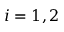<formula> <loc_0><loc_0><loc_500><loc_500>i = 1 , 2</formula> 